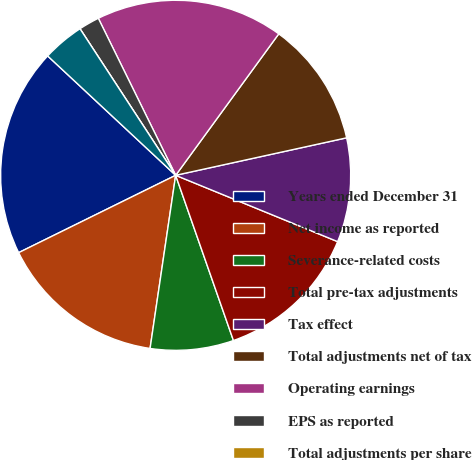Convert chart. <chart><loc_0><loc_0><loc_500><loc_500><pie_chart><fcel>Years ended December 31<fcel>Net income as reported<fcel>Severance-related costs<fcel>Total pre-tax adjustments<fcel>Tax effect<fcel>Total adjustments net of tax<fcel>Operating earnings<fcel>EPS as reported<fcel>Total adjustments per share<fcel>Operating EPS<nl><fcel>19.23%<fcel>15.38%<fcel>7.69%<fcel>13.46%<fcel>9.62%<fcel>11.54%<fcel>17.31%<fcel>1.92%<fcel>0.0%<fcel>3.85%<nl></chart> 